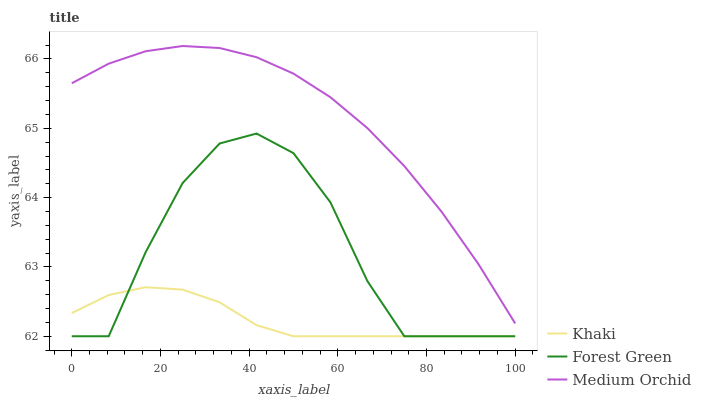Does Khaki have the minimum area under the curve?
Answer yes or no. Yes. Does Medium Orchid have the maximum area under the curve?
Answer yes or no. Yes. Does Medium Orchid have the minimum area under the curve?
Answer yes or no. No. Does Khaki have the maximum area under the curve?
Answer yes or no. No. Is Khaki the smoothest?
Answer yes or no. Yes. Is Forest Green the roughest?
Answer yes or no. Yes. Is Medium Orchid the smoothest?
Answer yes or no. No. Is Medium Orchid the roughest?
Answer yes or no. No. Does Medium Orchid have the lowest value?
Answer yes or no. No. Does Medium Orchid have the highest value?
Answer yes or no. Yes. Does Khaki have the highest value?
Answer yes or no. No. Is Khaki less than Medium Orchid?
Answer yes or no. Yes. Is Medium Orchid greater than Khaki?
Answer yes or no. Yes. Does Khaki intersect Forest Green?
Answer yes or no. Yes. Is Khaki less than Forest Green?
Answer yes or no. No. Is Khaki greater than Forest Green?
Answer yes or no. No. Does Khaki intersect Medium Orchid?
Answer yes or no. No. 